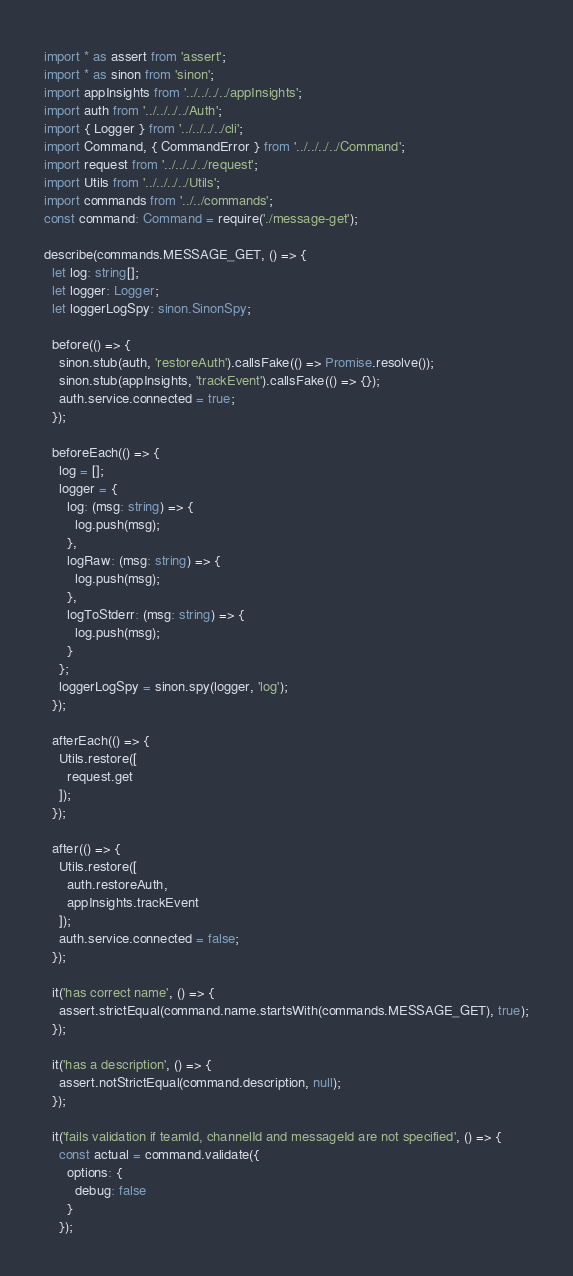Convert code to text. <code><loc_0><loc_0><loc_500><loc_500><_TypeScript_>import * as assert from 'assert';
import * as sinon from 'sinon';
import appInsights from '../../../../appInsights';
import auth from '../../../../Auth';
import { Logger } from '../../../../cli';
import Command, { CommandError } from '../../../../Command';
import request from '../../../../request';
import Utils from '../../../../Utils';
import commands from '../../commands';
const command: Command = require('./message-get');

describe(commands.MESSAGE_GET, () => {
  let log: string[];
  let logger: Logger;
  let loggerLogSpy: sinon.SinonSpy;

  before(() => {
    sinon.stub(auth, 'restoreAuth').callsFake(() => Promise.resolve());
    sinon.stub(appInsights, 'trackEvent').callsFake(() => {});
    auth.service.connected = true;
  });

  beforeEach(() => {
    log = [];
    logger = {
      log: (msg: string) => {
        log.push(msg);
      },
      logRaw: (msg: string) => {
        log.push(msg);
      },
      logToStderr: (msg: string) => {
        log.push(msg);
      }
    };
    loggerLogSpy = sinon.spy(logger, 'log');
  });

  afterEach(() => {
    Utils.restore([
      request.get
    ]);
  });

  after(() => {
    Utils.restore([
      auth.restoreAuth,
      appInsights.trackEvent
    ]);
    auth.service.connected = false;
  });

  it('has correct name', () => {
    assert.strictEqual(command.name.startsWith(commands.MESSAGE_GET), true);
  });

  it('has a description', () => {
    assert.notStrictEqual(command.description, null);
  });

  it('fails validation if teamId, channelId and messageId are not specified', () => {
    const actual = command.validate({
      options: {
        debug: false
      }
    });</code> 